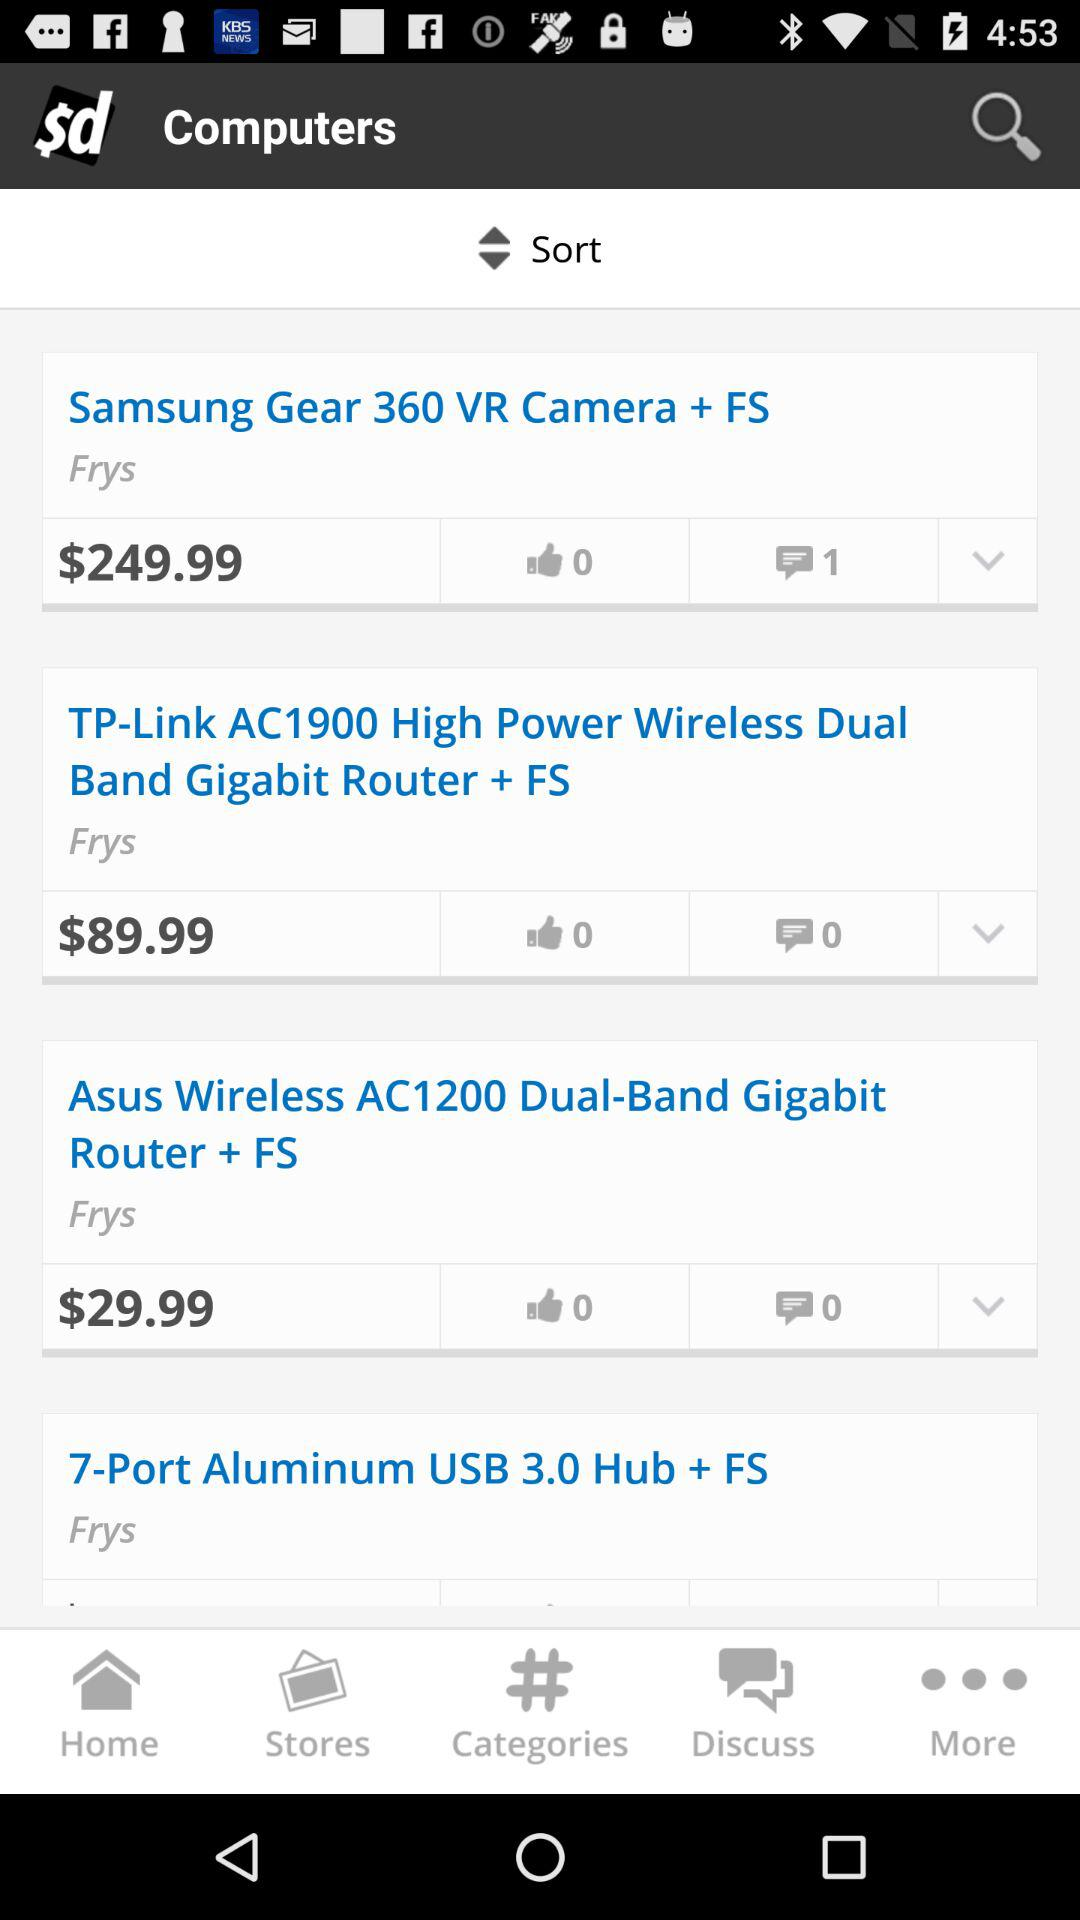What is the price of the "Samsung Gear 360 VR camera + FS"? The price of the "Samsung Gear 360 VR camera + FS" is $249.99. 